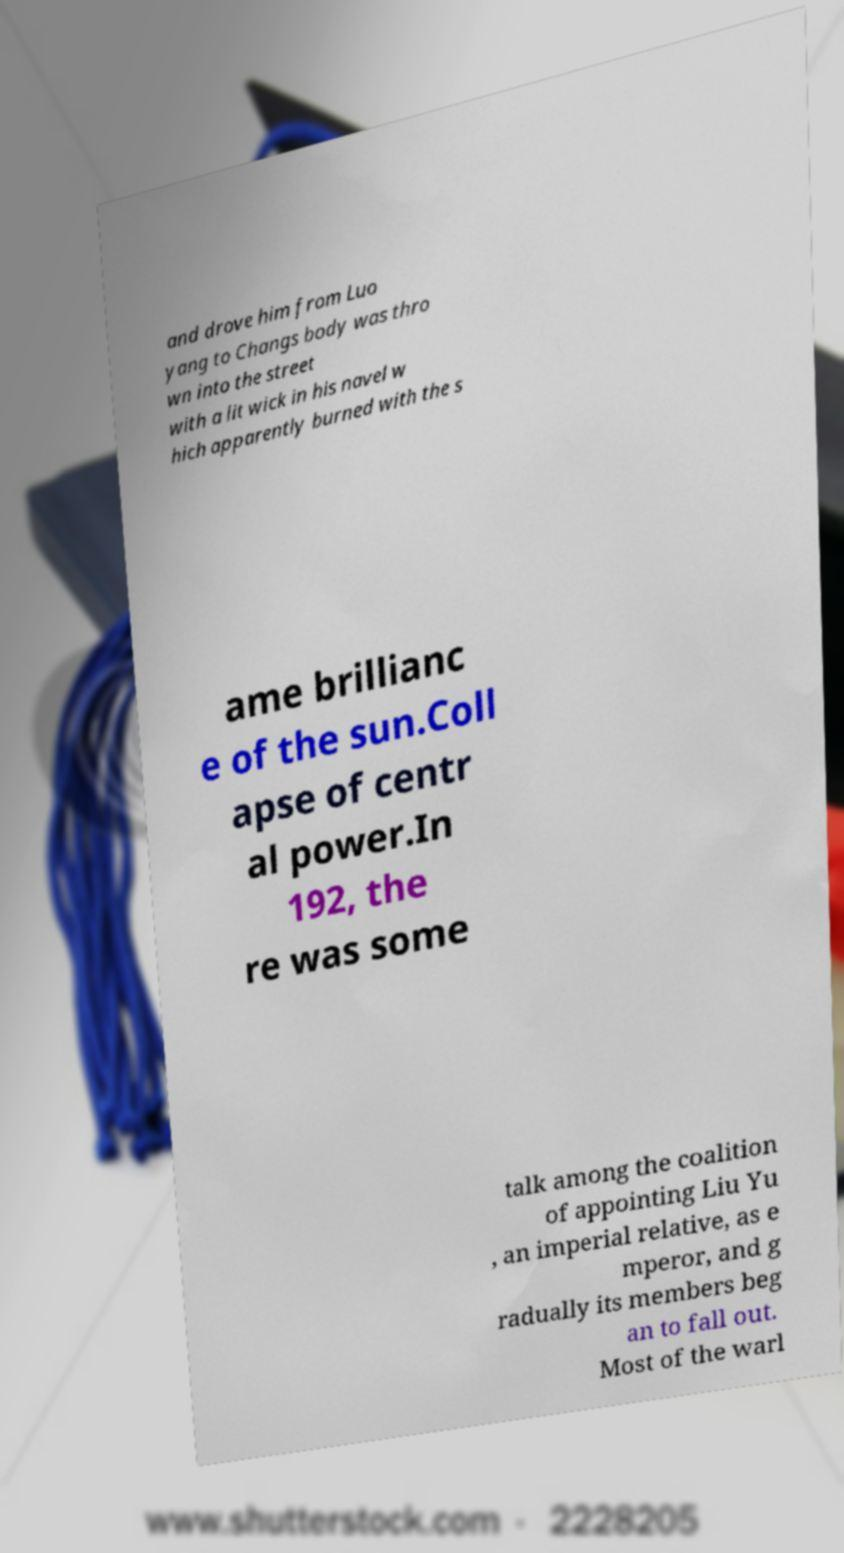I need the written content from this picture converted into text. Can you do that? and drove him from Luo yang to Changs body was thro wn into the street with a lit wick in his navel w hich apparently burned with the s ame brillianc e of the sun.Coll apse of centr al power.In 192, the re was some talk among the coalition of appointing Liu Yu , an imperial relative, as e mperor, and g radually its members beg an to fall out. Most of the warl 